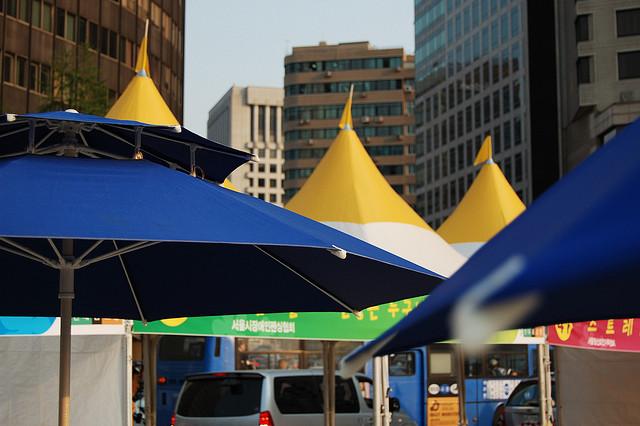How many umbrellas are there?
Write a very short answer. 5. Is this a countryside scene?
Give a very brief answer. No. Are there trees in the background?
Write a very short answer. No. 